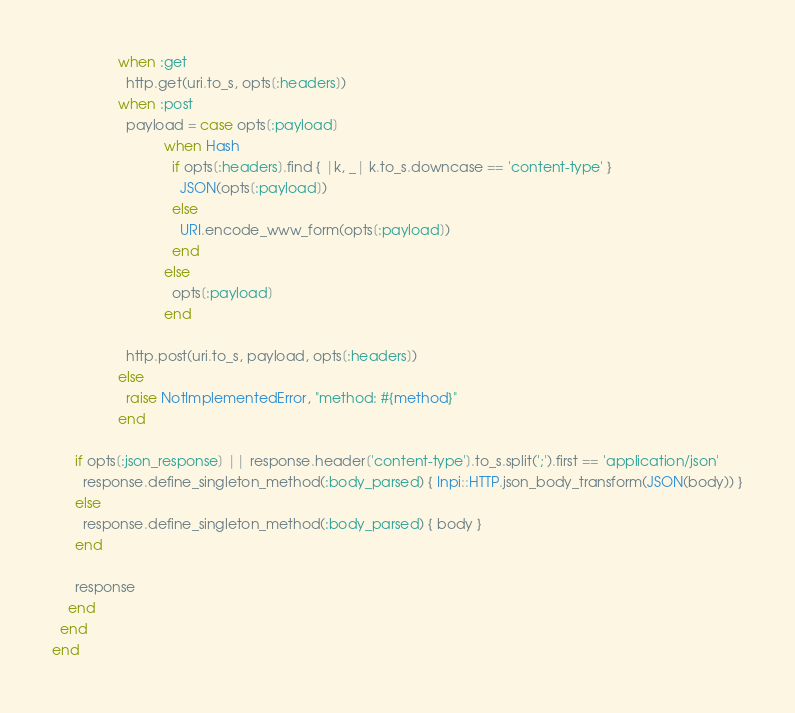Convert code to text. <code><loc_0><loc_0><loc_500><loc_500><_Ruby_>                 when :get
                   http.get(uri.to_s, opts[:headers])
                 when :post
                   payload = case opts[:payload]
                             when Hash
                               if opts[:headers].find { |k, _| k.to_s.downcase == 'content-type' }
                                 JSON(opts[:payload])
                               else
                                 URI.encode_www_form(opts[:payload])
                               end
                             else
                               opts[:payload]
                             end

                   http.post(uri.to_s, payload, opts[:headers])
                 else
                   raise NotImplementedError, "method: #{method}"
                 end

      if opts[:json_response] || response.header['content-type'].to_s.split(';').first == 'application/json'
        response.define_singleton_method(:body_parsed) { Inpi::HTTP.json_body_transform(JSON(body)) }
      else
        response.define_singleton_method(:body_parsed) { body }
      end

      response
    end
  end
end
</code> 